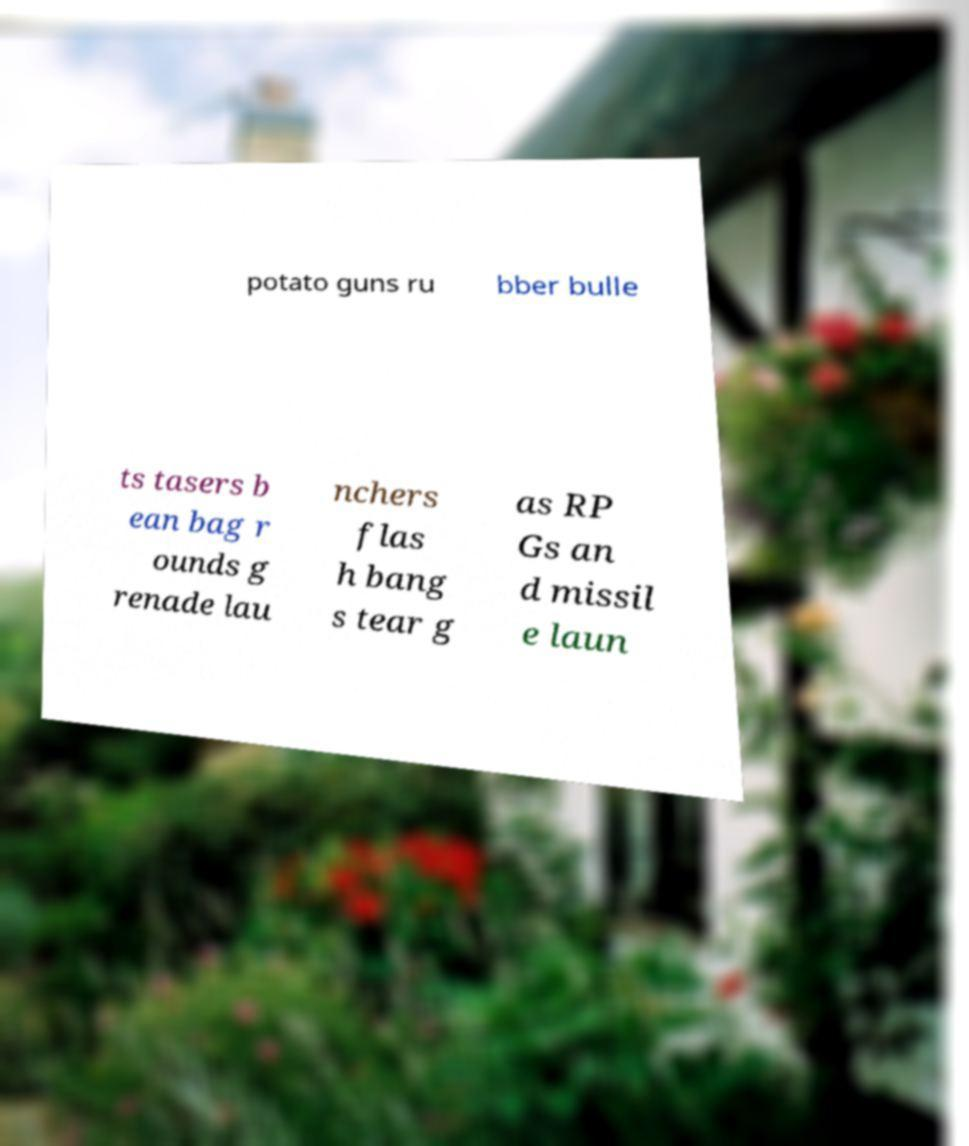There's text embedded in this image that I need extracted. Can you transcribe it verbatim? potato guns ru bber bulle ts tasers b ean bag r ounds g renade lau nchers flas h bang s tear g as RP Gs an d missil e laun 